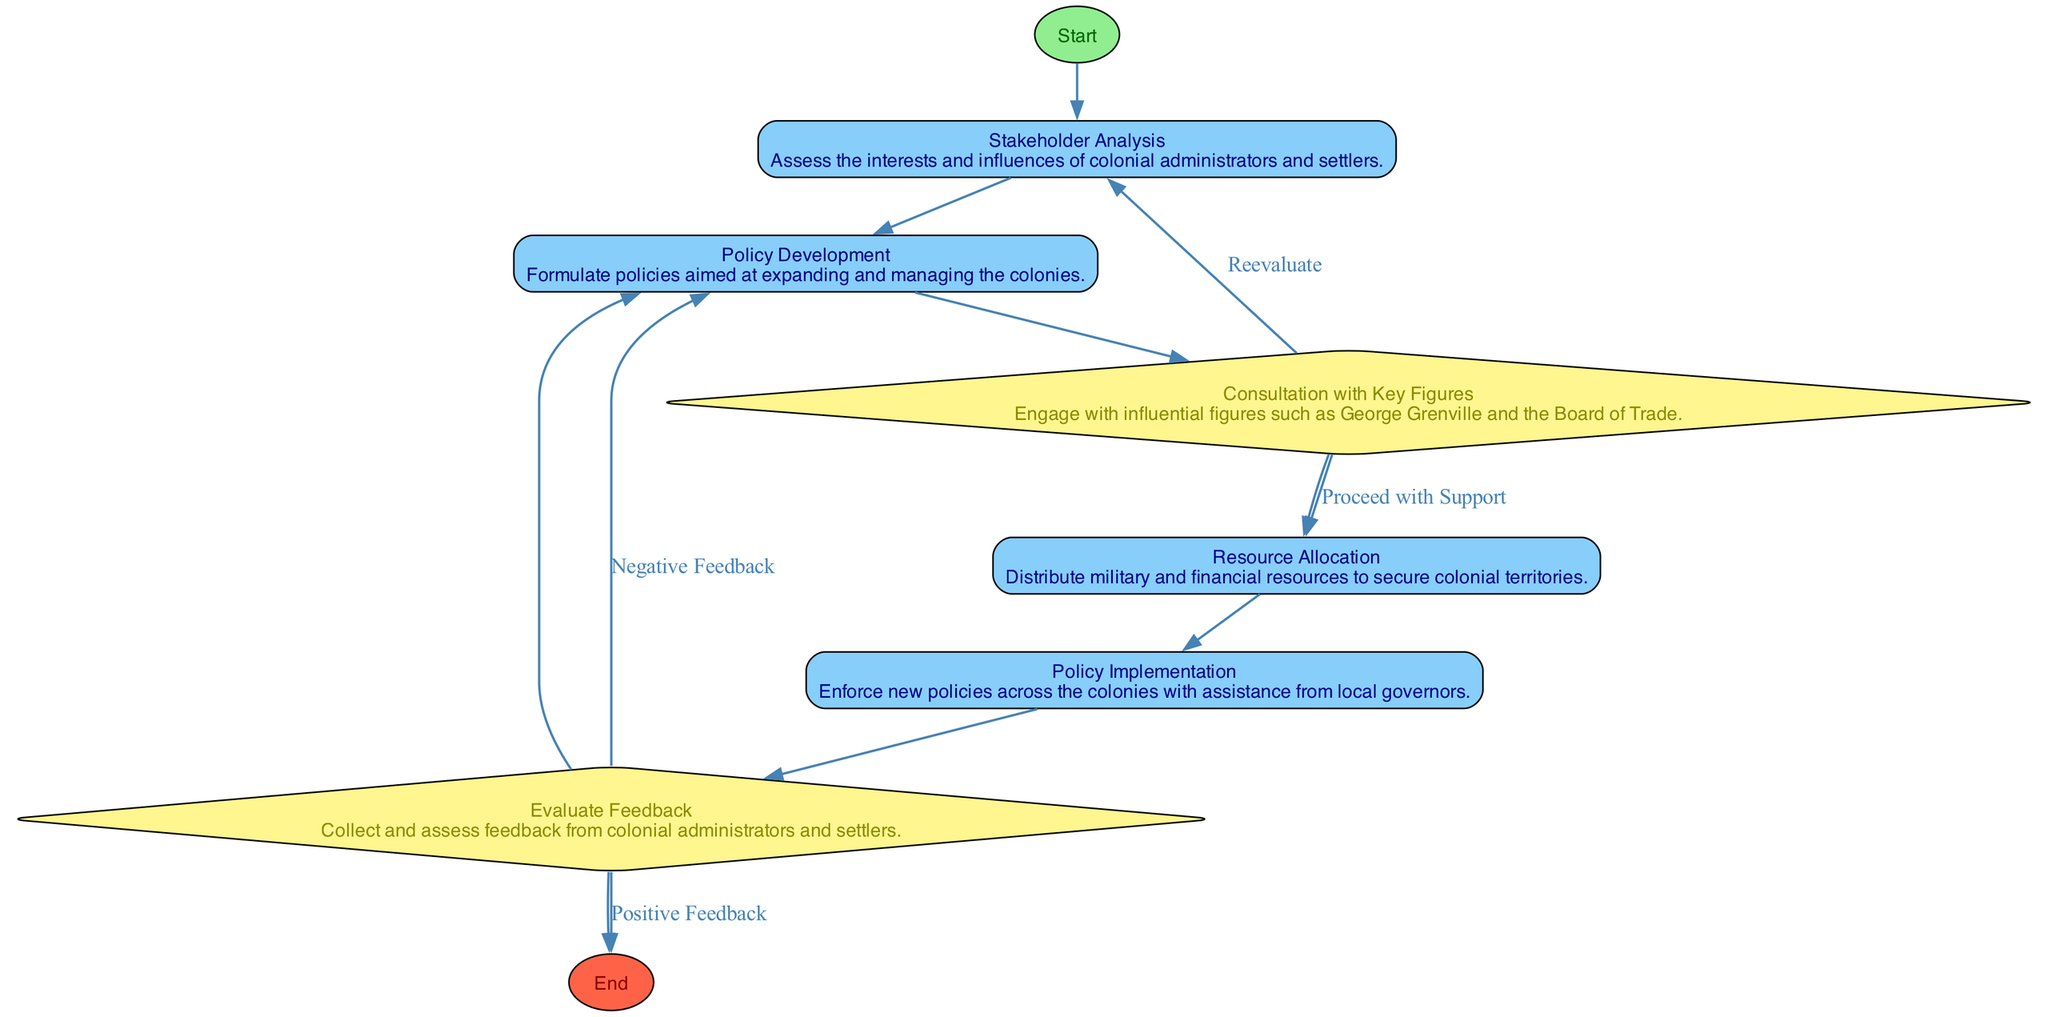What is the first step in the process? The first node in the diagram is labeled "Start". The flow begins with this step before proceeding to the next one, "Stakeholder Analysis".
Answer: Start How many decision nodes are in the diagram? There are two decision nodes in the diagram: "Consultation with Key Figures" and "Evaluate Feedback". Counting these gives a total of two decision nodes.
Answer: 2 What happens if the feedback is negative? If the feedback is negative, the process loops back to the "Policy Development" node according to the connections shown for the "Evaluate Feedback" decision node.
Answer: Policy Development Which node comes after "Resource Allocation"? The diagram indicates that "Implementation" follows "Resource Allocation" directly, connecting the two nodes as part of the process flow.
Answer: Implementation How many total nodes are in the diagram? The diagram lists seven nodes in total including the start and end nodes, which encompass all the relevant stages and decisions in William Pitt the Elder's impact on colonial policies.
Answer: 7 What is the final outcome if positive feedback is received? When positive feedback is received from "Evaluate Feedback", the process reaches the "End" node, signifying the completion of the outlined steps.
Answer: End What key figures are engaged during the consultation? The diagram specifies that key figures such as George Grenville and the Board of Trade are engaged during the "Consultation with Key Figures" step.
Answer: George Grenville and the Board of Trade What type of node is "Consultation with Key Figures"? "Consultation with Key Figures" is classified as a decision node in the diagram, which involves evaluating options based on external support received.
Answer: Decision Node 